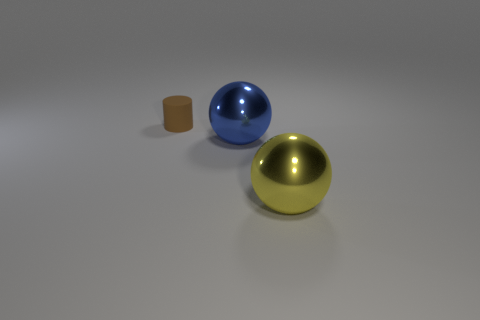Are there any other big objects of the same color as the matte object?
Keep it short and to the point. No. There is a sphere that is behind the big yellow thing; is its size the same as the metal thing that is in front of the large blue metal object?
Provide a succinct answer. Yes. Is the number of large blue balls on the left side of the large yellow ball greater than the number of small brown objects that are left of the brown thing?
Make the answer very short. Yes. Is there another sphere that has the same material as the yellow sphere?
Your answer should be compact. Yes. What color is the cylinder?
Provide a short and direct response. Brown. What number of other big blue things have the same shape as the blue metal object?
Your response must be concise. 0. Does the big sphere behind the yellow metal sphere have the same material as the large sphere in front of the blue shiny thing?
Provide a short and direct response. Yes. There is a thing on the left side of the ball behind the yellow sphere; what is its size?
Offer a terse response. Small. Are there any other things that have the same size as the cylinder?
Offer a very short reply. No. There is a metallic thing behind the yellow thing; is it the same shape as the large shiny thing that is in front of the large blue shiny ball?
Offer a terse response. Yes. 